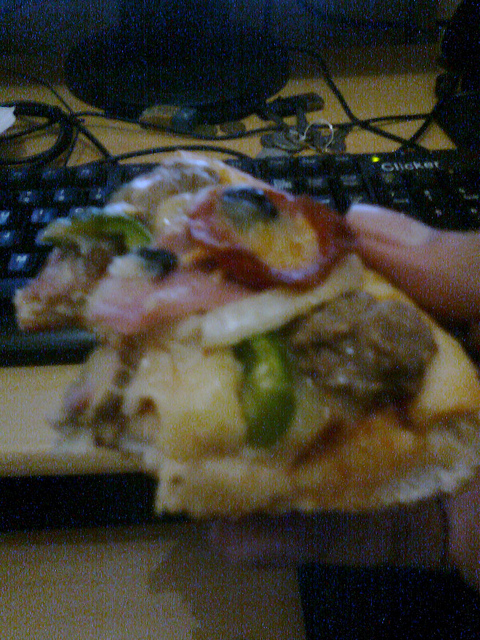What color bowls are pictured? The image doesn't show any bowls, focusing primarily on a slice of pizza. 